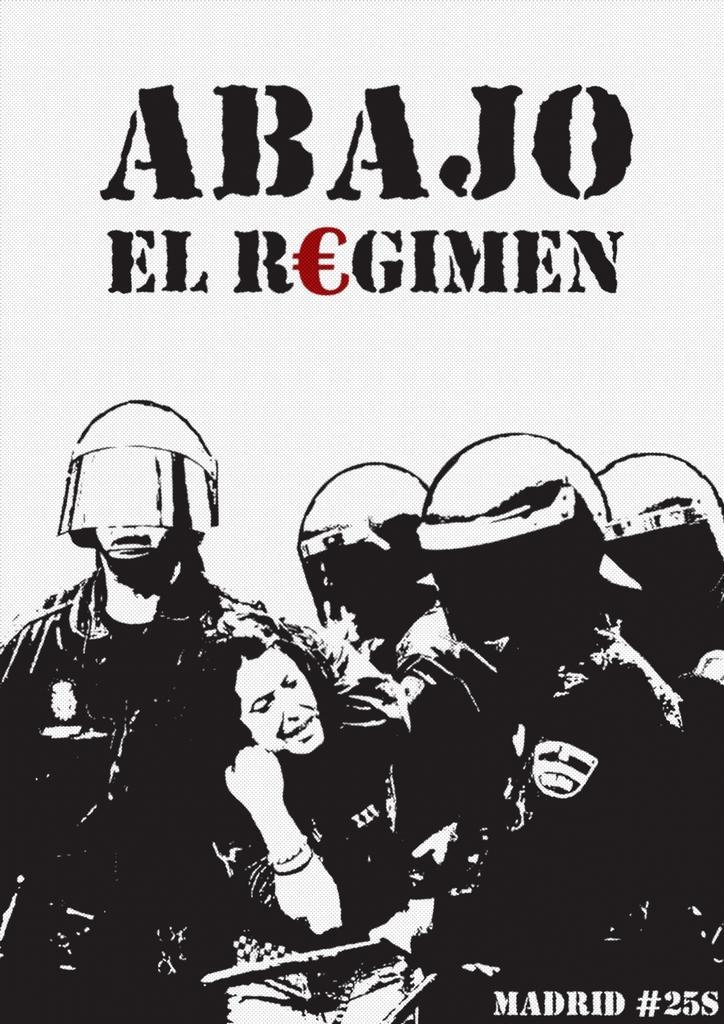How would you summarize this image in a sentence or two? The picture is looking like a poster. This is an edited picture. At the bottom there are men and women. The men are wearing helmets. At the top there is text. 